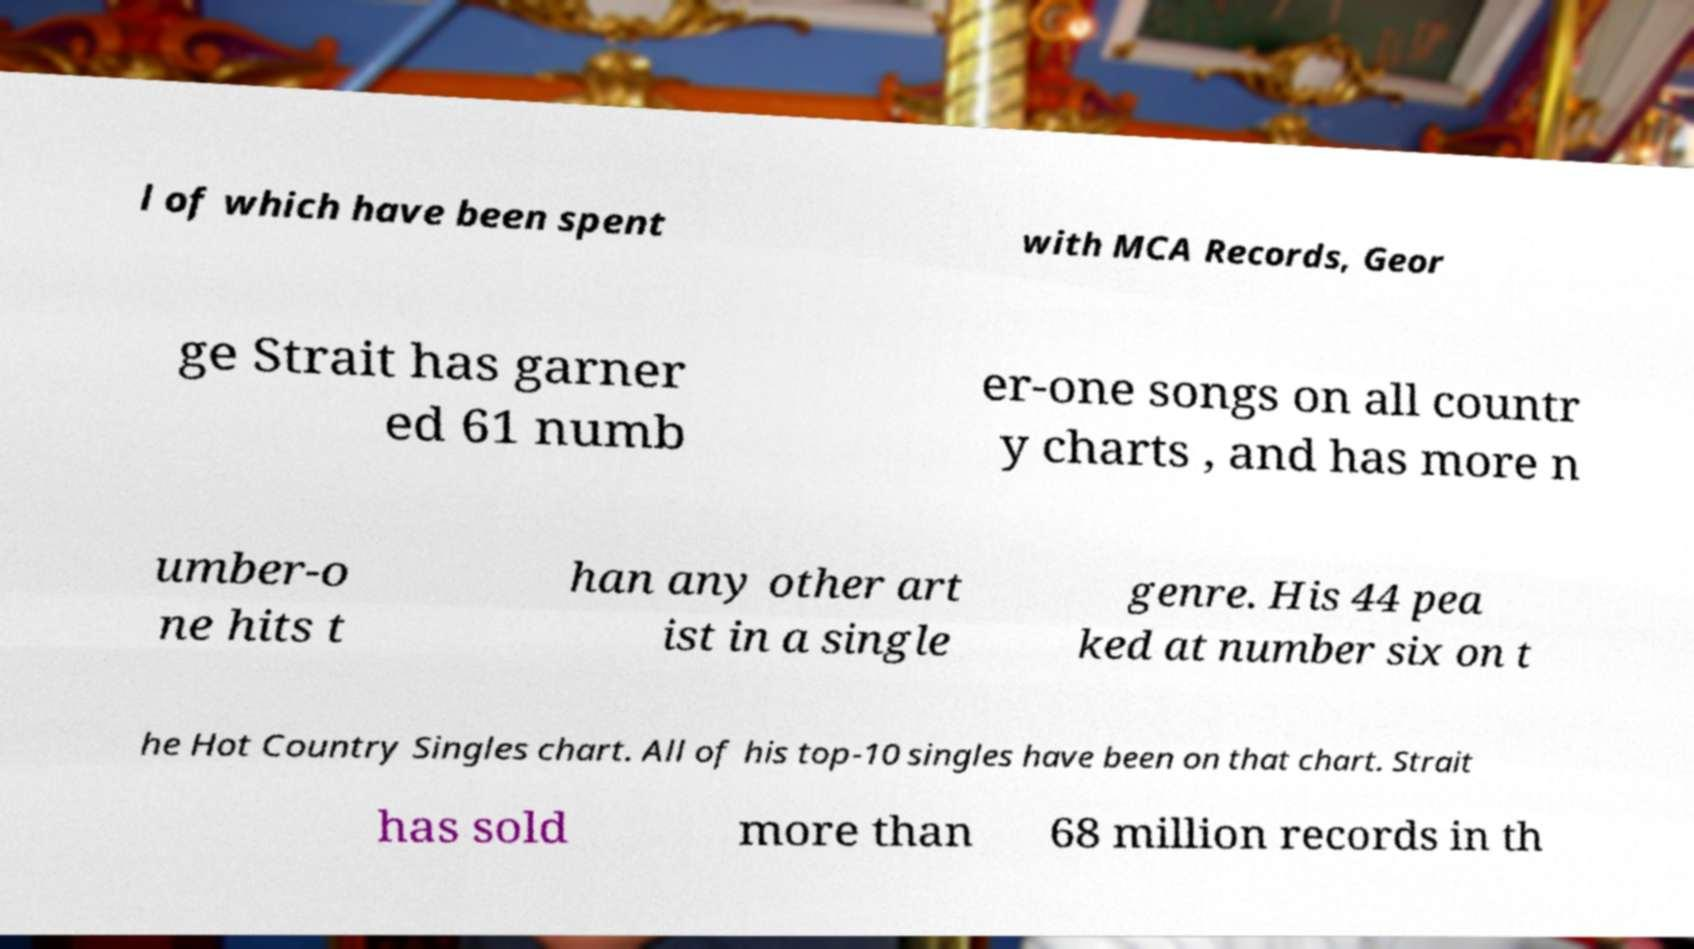Can you read and provide the text displayed in the image?This photo seems to have some interesting text. Can you extract and type it out for me? l of which have been spent with MCA Records, Geor ge Strait has garner ed 61 numb er-one songs on all countr y charts , and has more n umber-o ne hits t han any other art ist in a single genre. His 44 pea ked at number six on t he Hot Country Singles chart. All of his top-10 singles have been on that chart. Strait has sold more than 68 million records in th 